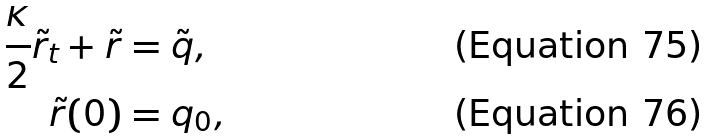<formula> <loc_0><loc_0><loc_500><loc_500>\frac { \kappa } { 2 } \tilde { r } _ { t } + \tilde { r } & = \tilde { q } , \\ \tilde { r } ( 0 ) & = q _ { 0 } ,</formula> 